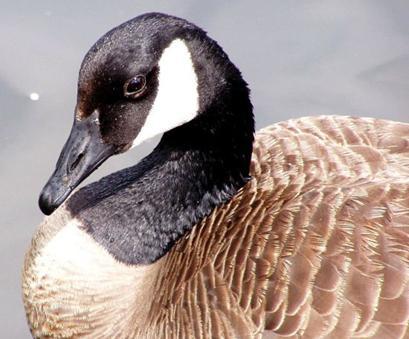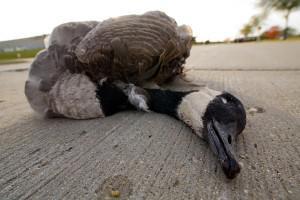The first image is the image on the left, the second image is the image on the right. For the images displayed, is the sentence "All the ducks are sleeping." factually correct? Answer yes or no. No. The first image is the image on the left, the second image is the image on the right. Considering the images on both sides, is "There are two birds in total." valid? Answer yes or no. Yes. 